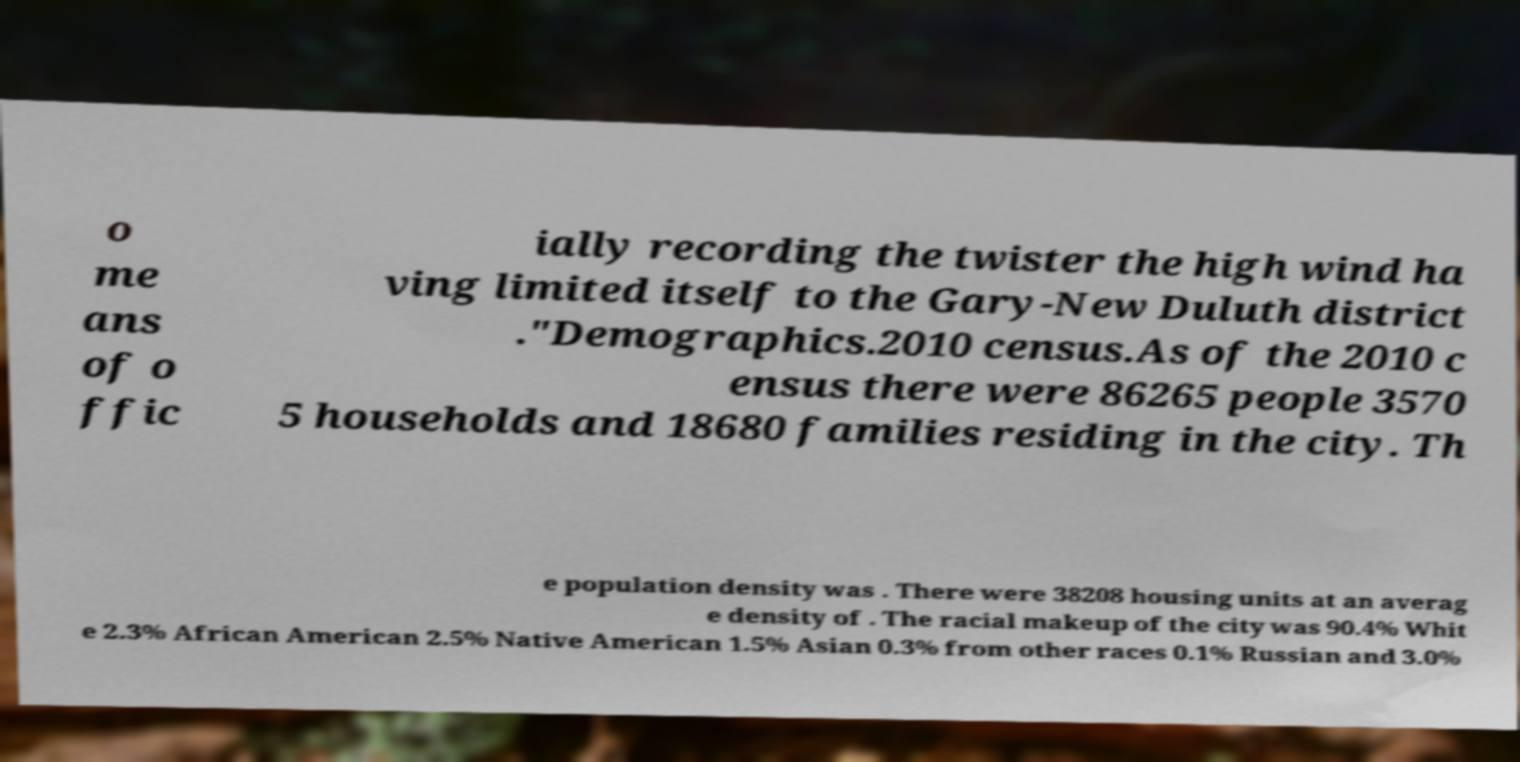There's text embedded in this image that I need extracted. Can you transcribe it verbatim? o me ans of o ffic ially recording the twister the high wind ha ving limited itself to the Gary-New Duluth district ."Demographics.2010 census.As of the 2010 c ensus there were 86265 people 3570 5 households and 18680 families residing in the city. Th e population density was . There were 38208 housing units at an averag e density of . The racial makeup of the city was 90.4% Whit e 2.3% African American 2.5% Native American 1.5% Asian 0.3% from other races 0.1% Russian and 3.0% 